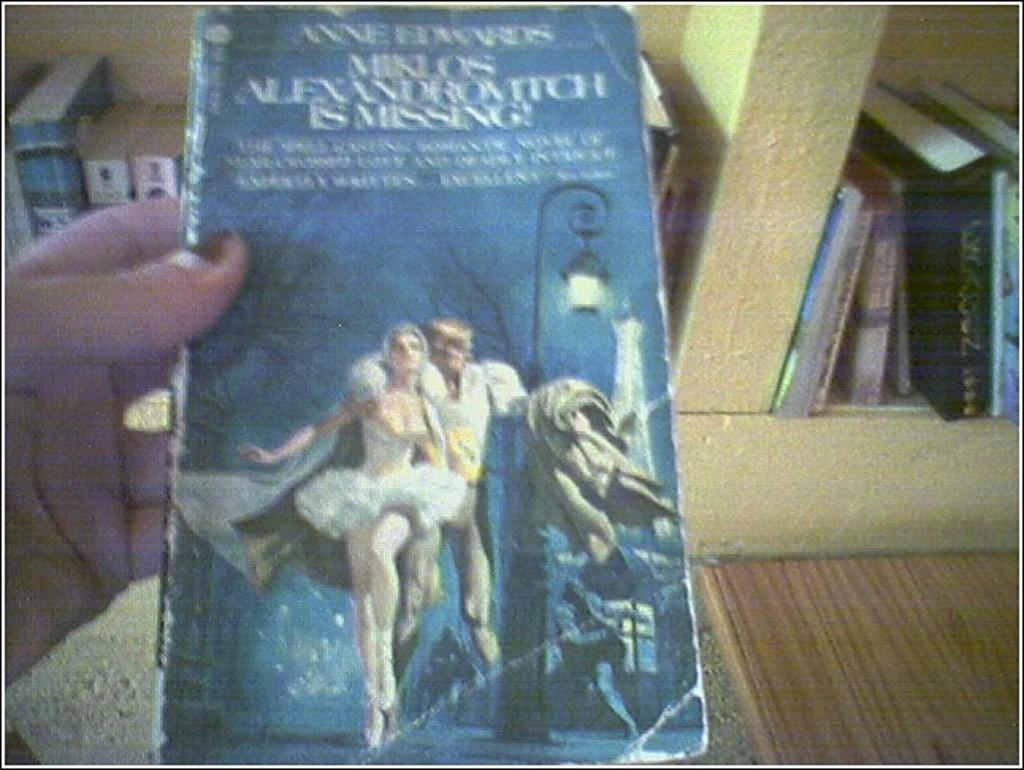<image>
Share a concise interpretation of the image provided. a book with a man and woman on the cover and the words is missing visible. 